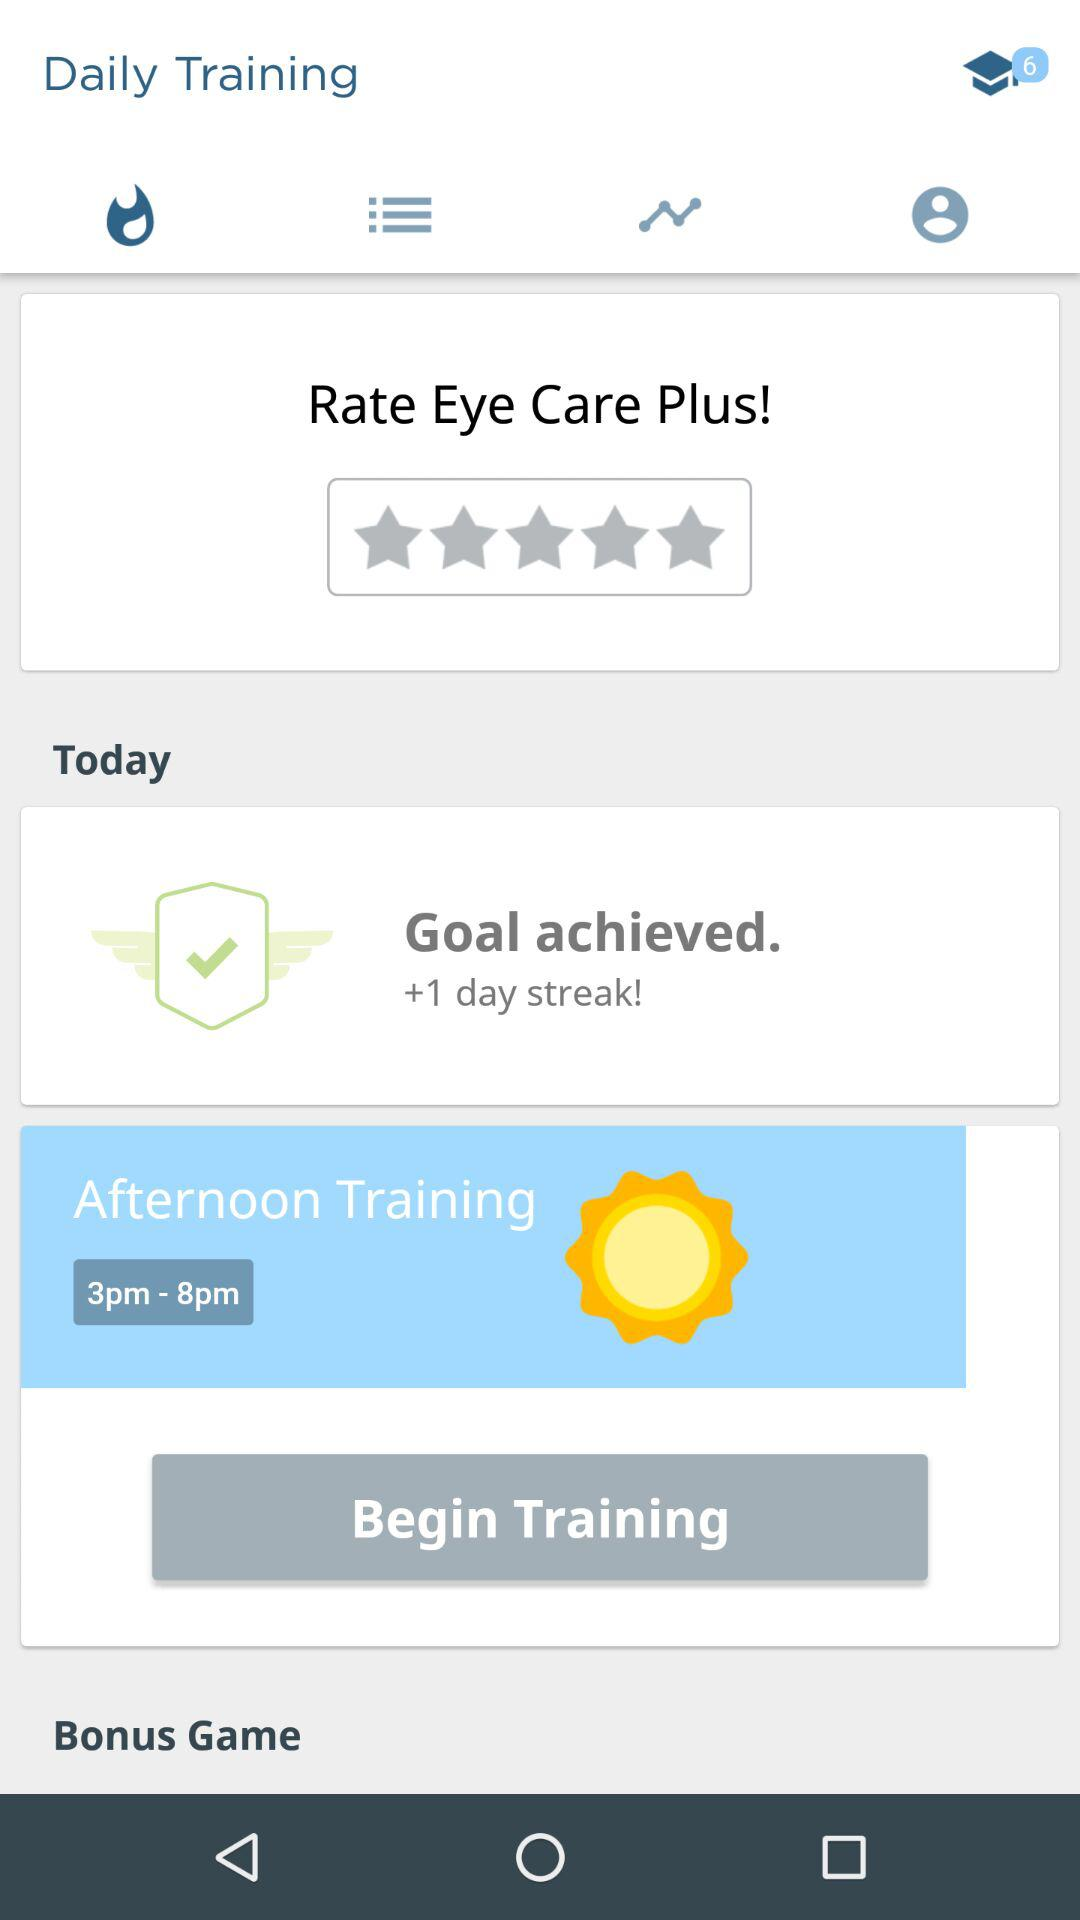When does morning training begin?
When the provided information is insufficient, respond with <no answer>. <no answer> 